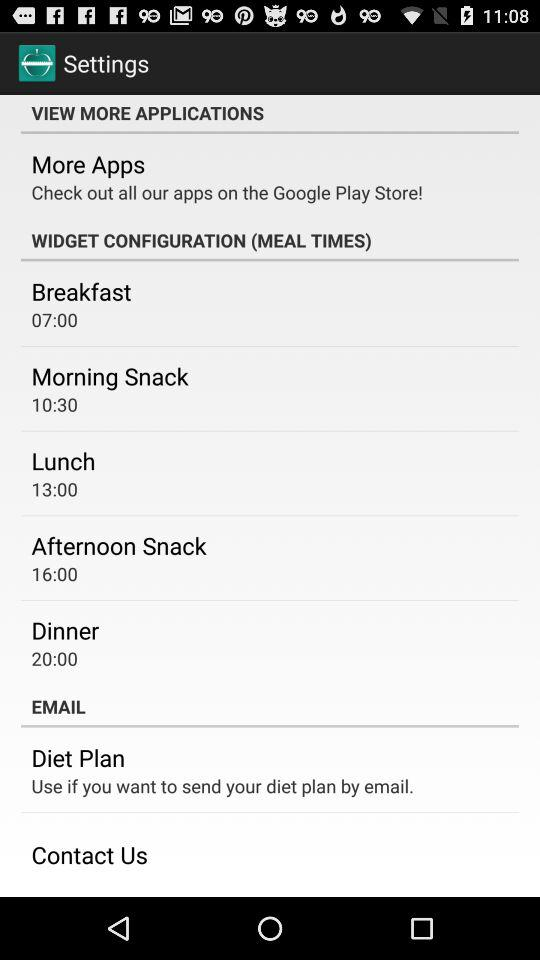What is the time for dinner? The time is 20:00. 